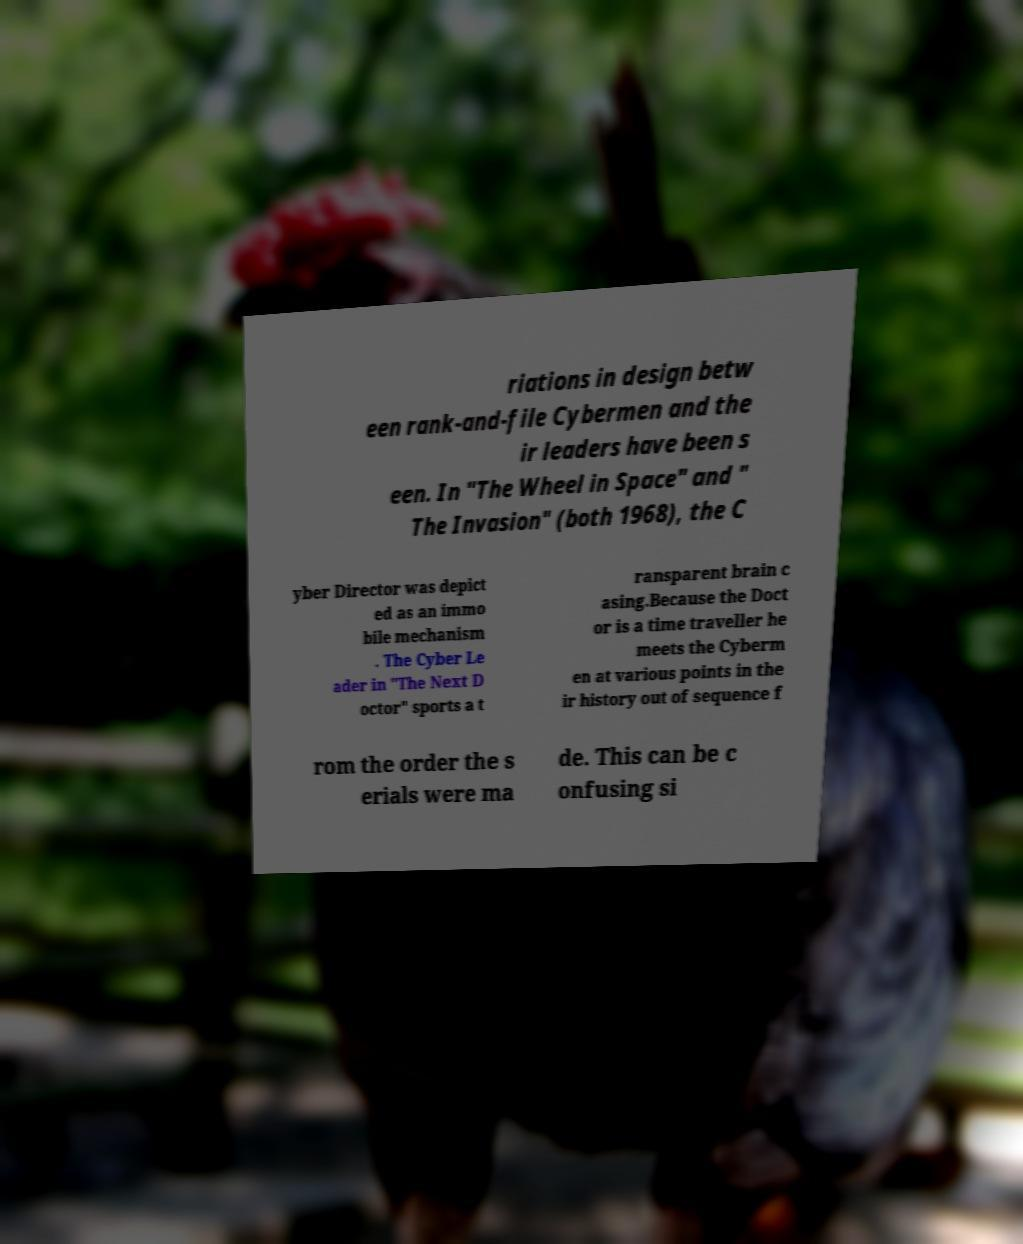There's text embedded in this image that I need extracted. Can you transcribe it verbatim? riations in design betw een rank-and-file Cybermen and the ir leaders have been s een. In "The Wheel in Space" and " The Invasion" (both 1968), the C yber Director was depict ed as an immo bile mechanism . The Cyber Le ader in "The Next D octor" sports a t ransparent brain c asing.Because the Doct or is a time traveller he meets the Cyberm en at various points in the ir history out of sequence f rom the order the s erials were ma de. This can be c onfusing si 